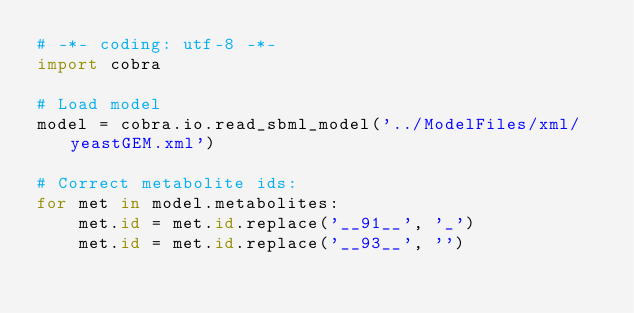<code> <loc_0><loc_0><loc_500><loc_500><_Python_># -*- coding: utf-8 -*-
import cobra

# Load model
model = cobra.io.read_sbml_model('../ModelFiles/xml/yeastGEM.xml')

# Correct metabolite ids:
for met in model.metabolites:
    met.id = met.id.replace('__91__', '_')
    met.id = met.id.replace('__93__', '')

</code> 